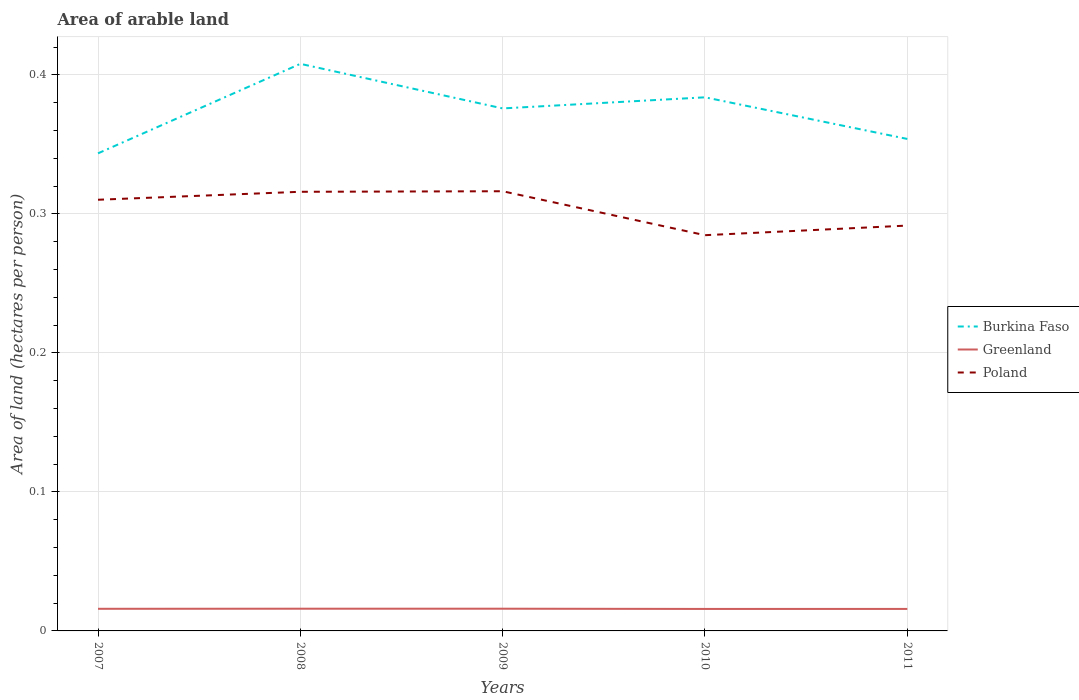Is the number of lines equal to the number of legend labels?
Your answer should be very brief. Yes. Across all years, what is the maximum total arable land in Poland?
Offer a terse response. 0.28. What is the total total arable land in Greenland in the graph?
Give a very brief answer. 0. What is the difference between the highest and the second highest total arable land in Burkina Faso?
Your answer should be very brief. 0.06. What is the difference between the highest and the lowest total arable land in Poland?
Keep it short and to the point. 3. Is the total arable land in Burkina Faso strictly greater than the total arable land in Poland over the years?
Keep it short and to the point. No. What is the difference between two consecutive major ticks on the Y-axis?
Provide a succinct answer. 0.1. Does the graph contain any zero values?
Make the answer very short. No. Does the graph contain grids?
Ensure brevity in your answer.  Yes. How many legend labels are there?
Your answer should be compact. 3. How are the legend labels stacked?
Offer a very short reply. Vertical. What is the title of the graph?
Provide a succinct answer. Area of arable land. What is the label or title of the Y-axis?
Provide a succinct answer. Area of land (hectares per person). What is the Area of land (hectares per person) of Burkina Faso in 2007?
Provide a short and direct response. 0.34. What is the Area of land (hectares per person) of Greenland in 2007?
Keep it short and to the point. 0.02. What is the Area of land (hectares per person) in Poland in 2007?
Your answer should be compact. 0.31. What is the Area of land (hectares per person) in Burkina Faso in 2008?
Your answer should be very brief. 0.41. What is the Area of land (hectares per person) in Greenland in 2008?
Offer a terse response. 0.02. What is the Area of land (hectares per person) in Poland in 2008?
Your answer should be compact. 0.32. What is the Area of land (hectares per person) of Burkina Faso in 2009?
Ensure brevity in your answer.  0.38. What is the Area of land (hectares per person) of Greenland in 2009?
Make the answer very short. 0.02. What is the Area of land (hectares per person) in Poland in 2009?
Make the answer very short. 0.32. What is the Area of land (hectares per person) of Burkina Faso in 2010?
Provide a succinct answer. 0.38. What is the Area of land (hectares per person) of Greenland in 2010?
Provide a short and direct response. 0.02. What is the Area of land (hectares per person) in Poland in 2010?
Your answer should be very brief. 0.28. What is the Area of land (hectares per person) of Burkina Faso in 2011?
Keep it short and to the point. 0.35. What is the Area of land (hectares per person) in Greenland in 2011?
Keep it short and to the point. 0.02. What is the Area of land (hectares per person) of Poland in 2011?
Offer a terse response. 0.29. Across all years, what is the maximum Area of land (hectares per person) of Burkina Faso?
Offer a terse response. 0.41. Across all years, what is the maximum Area of land (hectares per person) of Greenland?
Give a very brief answer. 0.02. Across all years, what is the maximum Area of land (hectares per person) in Poland?
Your answer should be compact. 0.32. Across all years, what is the minimum Area of land (hectares per person) in Burkina Faso?
Keep it short and to the point. 0.34. Across all years, what is the minimum Area of land (hectares per person) in Greenland?
Your answer should be very brief. 0.02. Across all years, what is the minimum Area of land (hectares per person) in Poland?
Keep it short and to the point. 0.28. What is the total Area of land (hectares per person) in Burkina Faso in the graph?
Offer a very short reply. 1.86. What is the total Area of land (hectares per person) in Greenland in the graph?
Provide a succinct answer. 0.08. What is the total Area of land (hectares per person) in Poland in the graph?
Give a very brief answer. 1.52. What is the difference between the Area of land (hectares per person) in Burkina Faso in 2007 and that in 2008?
Keep it short and to the point. -0.06. What is the difference between the Area of land (hectares per person) of Greenland in 2007 and that in 2008?
Your answer should be compact. -0. What is the difference between the Area of land (hectares per person) in Poland in 2007 and that in 2008?
Provide a succinct answer. -0.01. What is the difference between the Area of land (hectares per person) in Burkina Faso in 2007 and that in 2009?
Ensure brevity in your answer.  -0.03. What is the difference between the Area of land (hectares per person) of Greenland in 2007 and that in 2009?
Offer a terse response. -0. What is the difference between the Area of land (hectares per person) of Poland in 2007 and that in 2009?
Provide a short and direct response. -0.01. What is the difference between the Area of land (hectares per person) in Burkina Faso in 2007 and that in 2010?
Give a very brief answer. -0.04. What is the difference between the Area of land (hectares per person) of Poland in 2007 and that in 2010?
Ensure brevity in your answer.  0.03. What is the difference between the Area of land (hectares per person) in Burkina Faso in 2007 and that in 2011?
Give a very brief answer. -0.01. What is the difference between the Area of land (hectares per person) in Greenland in 2007 and that in 2011?
Your answer should be compact. 0. What is the difference between the Area of land (hectares per person) in Poland in 2007 and that in 2011?
Keep it short and to the point. 0.02. What is the difference between the Area of land (hectares per person) of Burkina Faso in 2008 and that in 2009?
Ensure brevity in your answer.  0.03. What is the difference between the Area of land (hectares per person) of Greenland in 2008 and that in 2009?
Your answer should be compact. -0. What is the difference between the Area of land (hectares per person) of Poland in 2008 and that in 2009?
Ensure brevity in your answer.  -0. What is the difference between the Area of land (hectares per person) in Burkina Faso in 2008 and that in 2010?
Your answer should be very brief. 0.02. What is the difference between the Area of land (hectares per person) of Greenland in 2008 and that in 2010?
Offer a terse response. 0. What is the difference between the Area of land (hectares per person) of Poland in 2008 and that in 2010?
Make the answer very short. 0.03. What is the difference between the Area of land (hectares per person) in Burkina Faso in 2008 and that in 2011?
Offer a very short reply. 0.05. What is the difference between the Area of land (hectares per person) of Poland in 2008 and that in 2011?
Make the answer very short. 0.02. What is the difference between the Area of land (hectares per person) of Burkina Faso in 2009 and that in 2010?
Your answer should be compact. -0.01. What is the difference between the Area of land (hectares per person) of Greenland in 2009 and that in 2010?
Provide a succinct answer. 0. What is the difference between the Area of land (hectares per person) in Poland in 2009 and that in 2010?
Your answer should be very brief. 0.03. What is the difference between the Area of land (hectares per person) of Burkina Faso in 2009 and that in 2011?
Keep it short and to the point. 0.02. What is the difference between the Area of land (hectares per person) in Greenland in 2009 and that in 2011?
Give a very brief answer. 0. What is the difference between the Area of land (hectares per person) in Poland in 2009 and that in 2011?
Offer a very short reply. 0.02. What is the difference between the Area of land (hectares per person) of Burkina Faso in 2010 and that in 2011?
Provide a succinct answer. 0.03. What is the difference between the Area of land (hectares per person) in Poland in 2010 and that in 2011?
Offer a terse response. -0.01. What is the difference between the Area of land (hectares per person) in Burkina Faso in 2007 and the Area of land (hectares per person) in Greenland in 2008?
Keep it short and to the point. 0.33. What is the difference between the Area of land (hectares per person) in Burkina Faso in 2007 and the Area of land (hectares per person) in Poland in 2008?
Keep it short and to the point. 0.03. What is the difference between the Area of land (hectares per person) in Greenland in 2007 and the Area of land (hectares per person) in Poland in 2008?
Your answer should be very brief. -0.3. What is the difference between the Area of land (hectares per person) in Burkina Faso in 2007 and the Area of land (hectares per person) in Greenland in 2009?
Your answer should be compact. 0.33. What is the difference between the Area of land (hectares per person) in Burkina Faso in 2007 and the Area of land (hectares per person) in Poland in 2009?
Your answer should be compact. 0.03. What is the difference between the Area of land (hectares per person) in Greenland in 2007 and the Area of land (hectares per person) in Poland in 2009?
Give a very brief answer. -0.3. What is the difference between the Area of land (hectares per person) of Burkina Faso in 2007 and the Area of land (hectares per person) of Greenland in 2010?
Make the answer very short. 0.33. What is the difference between the Area of land (hectares per person) of Burkina Faso in 2007 and the Area of land (hectares per person) of Poland in 2010?
Make the answer very short. 0.06. What is the difference between the Area of land (hectares per person) in Greenland in 2007 and the Area of land (hectares per person) in Poland in 2010?
Your answer should be compact. -0.27. What is the difference between the Area of land (hectares per person) of Burkina Faso in 2007 and the Area of land (hectares per person) of Greenland in 2011?
Give a very brief answer. 0.33. What is the difference between the Area of land (hectares per person) in Burkina Faso in 2007 and the Area of land (hectares per person) in Poland in 2011?
Provide a succinct answer. 0.05. What is the difference between the Area of land (hectares per person) in Greenland in 2007 and the Area of land (hectares per person) in Poland in 2011?
Offer a very short reply. -0.28. What is the difference between the Area of land (hectares per person) in Burkina Faso in 2008 and the Area of land (hectares per person) in Greenland in 2009?
Keep it short and to the point. 0.39. What is the difference between the Area of land (hectares per person) in Burkina Faso in 2008 and the Area of land (hectares per person) in Poland in 2009?
Offer a very short reply. 0.09. What is the difference between the Area of land (hectares per person) in Greenland in 2008 and the Area of land (hectares per person) in Poland in 2009?
Provide a short and direct response. -0.3. What is the difference between the Area of land (hectares per person) of Burkina Faso in 2008 and the Area of land (hectares per person) of Greenland in 2010?
Ensure brevity in your answer.  0.39. What is the difference between the Area of land (hectares per person) in Burkina Faso in 2008 and the Area of land (hectares per person) in Poland in 2010?
Make the answer very short. 0.12. What is the difference between the Area of land (hectares per person) of Greenland in 2008 and the Area of land (hectares per person) of Poland in 2010?
Ensure brevity in your answer.  -0.27. What is the difference between the Area of land (hectares per person) of Burkina Faso in 2008 and the Area of land (hectares per person) of Greenland in 2011?
Make the answer very short. 0.39. What is the difference between the Area of land (hectares per person) in Burkina Faso in 2008 and the Area of land (hectares per person) in Poland in 2011?
Provide a succinct answer. 0.12. What is the difference between the Area of land (hectares per person) in Greenland in 2008 and the Area of land (hectares per person) in Poland in 2011?
Your answer should be very brief. -0.28. What is the difference between the Area of land (hectares per person) of Burkina Faso in 2009 and the Area of land (hectares per person) of Greenland in 2010?
Your answer should be very brief. 0.36. What is the difference between the Area of land (hectares per person) in Burkina Faso in 2009 and the Area of land (hectares per person) in Poland in 2010?
Keep it short and to the point. 0.09. What is the difference between the Area of land (hectares per person) in Greenland in 2009 and the Area of land (hectares per person) in Poland in 2010?
Provide a short and direct response. -0.27. What is the difference between the Area of land (hectares per person) in Burkina Faso in 2009 and the Area of land (hectares per person) in Greenland in 2011?
Offer a very short reply. 0.36. What is the difference between the Area of land (hectares per person) in Burkina Faso in 2009 and the Area of land (hectares per person) in Poland in 2011?
Your response must be concise. 0.08. What is the difference between the Area of land (hectares per person) of Greenland in 2009 and the Area of land (hectares per person) of Poland in 2011?
Ensure brevity in your answer.  -0.28. What is the difference between the Area of land (hectares per person) of Burkina Faso in 2010 and the Area of land (hectares per person) of Greenland in 2011?
Make the answer very short. 0.37. What is the difference between the Area of land (hectares per person) of Burkina Faso in 2010 and the Area of land (hectares per person) of Poland in 2011?
Make the answer very short. 0.09. What is the difference between the Area of land (hectares per person) in Greenland in 2010 and the Area of land (hectares per person) in Poland in 2011?
Your answer should be compact. -0.28. What is the average Area of land (hectares per person) of Burkina Faso per year?
Provide a succinct answer. 0.37. What is the average Area of land (hectares per person) of Greenland per year?
Provide a succinct answer. 0.02. What is the average Area of land (hectares per person) of Poland per year?
Your answer should be compact. 0.3. In the year 2007, what is the difference between the Area of land (hectares per person) in Burkina Faso and Area of land (hectares per person) in Greenland?
Offer a very short reply. 0.33. In the year 2007, what is the difference between the Area of land (hectares per person) of Burkina Faso and Area of land (hectares per person) of Poland?
Give a very brief answer. 0.03. In the year 2007, what is the difference between the Area of land (hectares per person) of Greenland and Area of land (hectares per person) of Poland?
Ensure brevity in your answer.  -0.29. In the year 2008, what is the difference between the Area of land (hectares per person) of Burkina Faso and Area of land (hectares per person) of Greenland?
Your answer should be very brief. 0.39. In the year 2008, what is the difference between the Area of land (hectares per person) of Burkina Faso and Area of land (hectares per person) of Poland?
Your response must be concise. 0.09. In the year 2008, what is the difference between the Area of land (hectares per person) of Greenland and Area of land (hectares per person) of Poland?
Provide a short and direct response. -0.3. In the year 2009, what is the difference between the Area of land (hectares per person) in Burkina Faso and Area of land (hectares per person) in Greenland?
Your answer should be compact. 0.36. In the year 2009, what is the difference between the Area of land (hectares per person) in Burkina Faso and Area of land (hectares per person) in Poland?
Your answer should be very brief. 0.06. In the year 2009, what is the difference between the Area of land (hectares per person) in Greenland and Area of land (hectares per person) in Poland?
Your response must be concise. -0.3. In the year 2010, what is the difference between the Area of land (hectares per person) in Burkina Faso and Area of land (hectares per person) in Greenland?
Give a very brief answer. 0.37. In the year 2010, what is the difference between the Area of land (hectares per person) of Burkina Faso and Area of land (hectares per person) of Poland?
Give a very brief answer. 0.1. In the year 2010, what is the difference between the Area of land (hectares per person) of Greenland and Area of land (hectares per person) of Poland?
Offer a very short reply. -0.27. In the year 2011, what is the difference between the Area of land (hectares per person) of Burkina Faso and Area of land (hectares per person) of Greenland?
Provide a short and direct response. 0.34. In the year 2011, what is the difference between the Area of land (hectares per person) of Burkina Faso and Area of land (hectares per person) of Poland?
Provide a succinct answer. 0.06. In the year 2011, what is the difference between the Area of land (hectares per person) of Greenland and Area of land (hectares per person) of Poland?
Your answer should be very brief. -0.28. What is the ratio of the Area of land (hectares per person) in Burkina Faso in 2007 to that in 2008?
Make the answer very short. 0.84. What is the ratio of the Area of land (hectares per person) of Greenland in 2007 to that in 2008?
Provide a short and direct response. 1. What is the ratio of the Area of land (hectares per person) in Poland in 2007 to that in 2008?
Ensure brevity in your answer.  0.98. What is the ratio of the Area of land (hectares per person) in Burkina Faso in 2007 to that in 2009?
Your answer should be very brief. 0.91. What is the ratio of the Area of land (hectares per person) of Greenland in 2007 to that in 2009?
Your answer should be very brief. 1. What is the ratio of the Area of land (hectares per person) in Poland in 2007 to that in 2009?
Your answer should be compact. 0.98. What is the ratio of the Area of land (hectares per person) of Burkina Faso in 2007 to that in 2010?
Make the answer very short. 0.9. What is the ratio of the Area of land (hectares per person) of Greenland in 2007 to that in 2010?
Give a very brief answer. 1.01. What is the ratio of the Area of land (hectares per person) of Poland in 2007 to that in 2010?
Ensure brevity in your answer.  1.09. What is the ratio of the Area of land (hectares per person) of Burkina Faso in 2007 to that in 2011?
Make the answer very short. 0.97. What is the ratio of the Area of land (hectares per person) in Greenland in 2007 to that in 2011?
Give a very brief answer. 1.01. What is the ratio of the Area of land (hectares per person) in Poland in 2007 to that in 2011?
Provide a succinct answer. 1.06. What is the ratio of the Area of land (hectares per person) of Burkina Faso in 2008 to that in 2009?
Offer a very short reply. 1.09. What is the ratio of the Area of land (hectares per person) in Greenland in 2008 to that in 2009?
Provide a succinct answer. 1. What is the ratio of the Area of land (hectares per person) of Burkina Faso in 2008 to that in 2010?
Offer a terse response. 1.06. What is the ratio of the Area of land (hectares per person) of Greenland in 2008 to that in 2010?
Keep it short and to the point. 1.01. What is the ratio of the Area of land (hectares per person) in Poland in 2008 to that in 2010?
Offer a very short reply. 1.11. What is the ratio of the Area of land (hectares per person) of Burkina Faso in 2008 to that in 2011?
Offer a very short reply. 1.15. What is the ratio of the Area of land (hectares per person) in Poland in 2008 to that in 2011?
Provide a short and direct response. 1.08. What is the ratio of the Area of land (hectares per person) in Burkina Faso in 2009 to that in 2010?
Keep it short and to the point. 0.98. What is the ratio of the Area of land (hectares per person) of Greenland in 2009 to that in 2010?
Offer a very short reply. 1.01. What is the ratio of the Area of land (hectares per person) of Burkina Faso in 2009 to that in 2011?
Provide a succinct answer. 1.06. What is the ratio of the Area of land (hectares per person) in Poland in 2009 to that in 2011?
Ensure brevity in your answer.  1.08. What is the ratio of the Area of land (hectares per person) of Burkina Faso in 2010 to that in 2011?
Provide a short and direct response. 1.08. What is the ratio of the Area of land (hectares per person) of Poland in 2010 to that in 2011?
Give a very brief answer. 0.98. What is the difference between the highest and the second highest Area of land (hectares per person) in Burkina Faso?
Ensure brevity in your answer.  0.02. What is the difference between the highest and the lowest Area of land (hectares per person) of Burkina Faso?
Your answer should be very brief. 0.06. What is the difference between the highest and the lowest Area of land (hectares per person) in Greenland?
Provide a succinct answer. 0. What is the difference between the highest and the lowest Area of land (hectares per person) of Poland?
Offer a terse response. 0.03. 